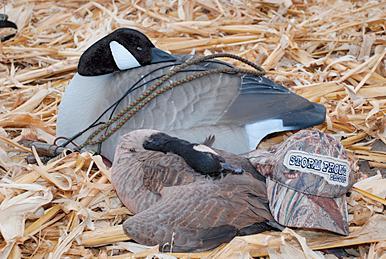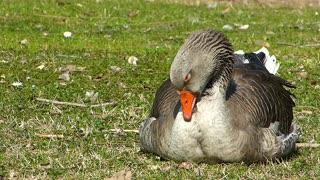The first image is the image on the left, the second image is the image on the right. Analyze the images presented: Is the assertion "A single bird has its head in its feathers." valid? Answer yes or no. No. The first image is the image on the left, the second image is the image on the right. Evaluate the accuracy of this statement regarding the images: "There are two birds in total.". Is it true? Answer yes or no. No. 